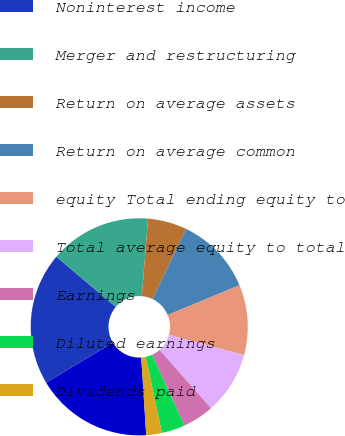<chart> <loc_0><loc_0><loc_500><loc_500><pie_chart><fcel>Net interest income<fcel>Noninterest income<fcel>Merger and restructuring<fcel>Return on average assets<fcel>Return on average common<fcel>equity Total ending equity to<fcel>Total average equity to total<fcel>Earnings<fcel>Diluted earnings<fcel>Dividends paid<nl><fcel>17.44%<fcel>19.77%<fcel>15.12%<fcel>5.81%<fcel>11.63%<fcel>10.47%<fcel>9.3%<fcel>4.65%<fcel>3.49%<fcel>2.33%<nl></chart> 